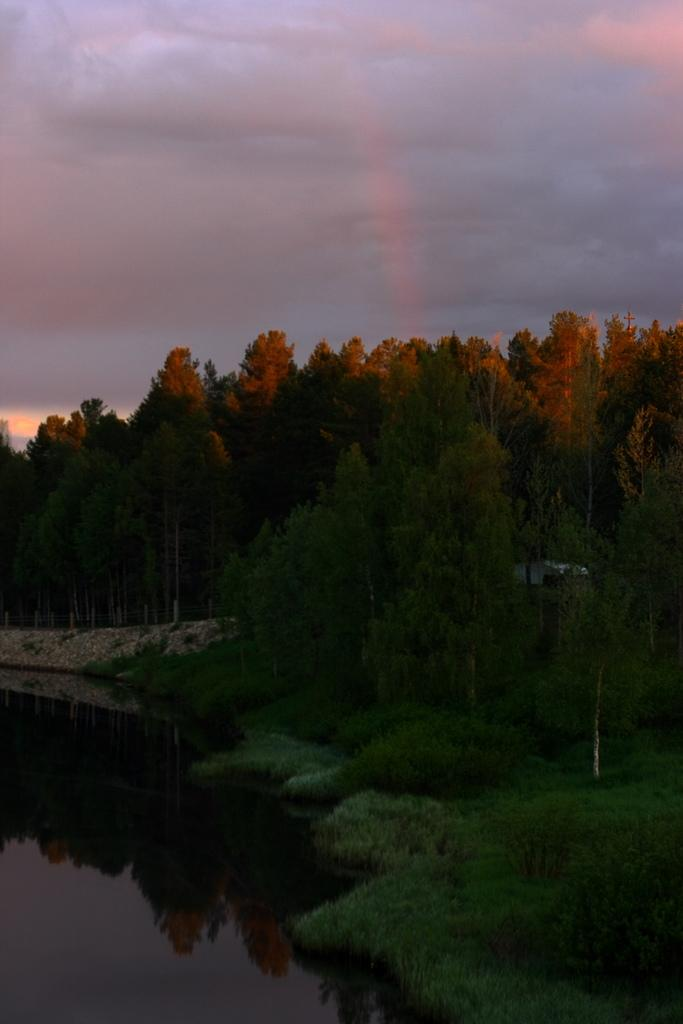What can be seen in the sky in the image? The sky with clouds is visible in the image. What type of vegetation is present in the image? There are trees in the image. What material is present in the image that is not vegetation or water? Stones are present in the image. What is the body of water in the image? There is water visible in the image. What type of ground cover is present in the image? Grass is present in the image. Where is the shelf located in the image? There is no shelf present in the image. What type of crime is being committed in the image? There is no crime or criminal activity depicted in the image. 